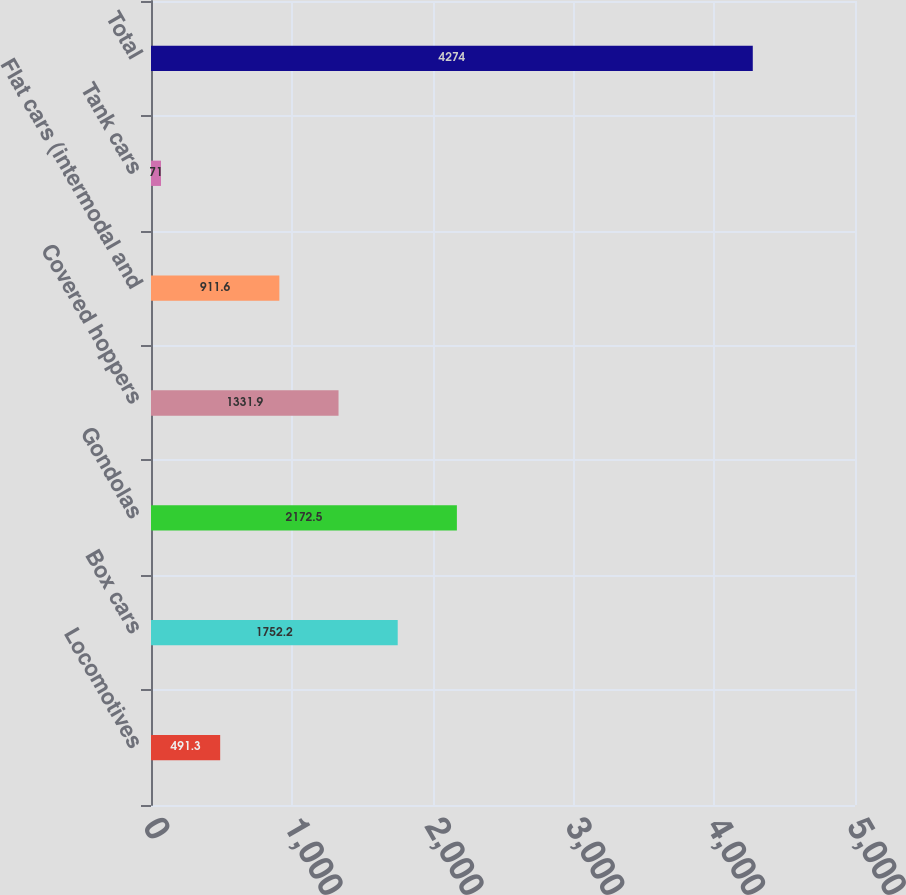Convert chart to OTSL. <chart><loc_0><loc_0><loc_500><loc_500><bar_chart><fcel>Locomotives<fcel>Box cars<fcel>Gondolas<fcel>Covered hoppers<fcel>Flat cars (intermodal and<fcel>Tank cars<fcel>Total<nl><fcel>491.3<fcel>1752.2<fcel>2172.5<fcel>1331.9<fcel>911.6<fcel>71<fcel>4274<nl></chart> 